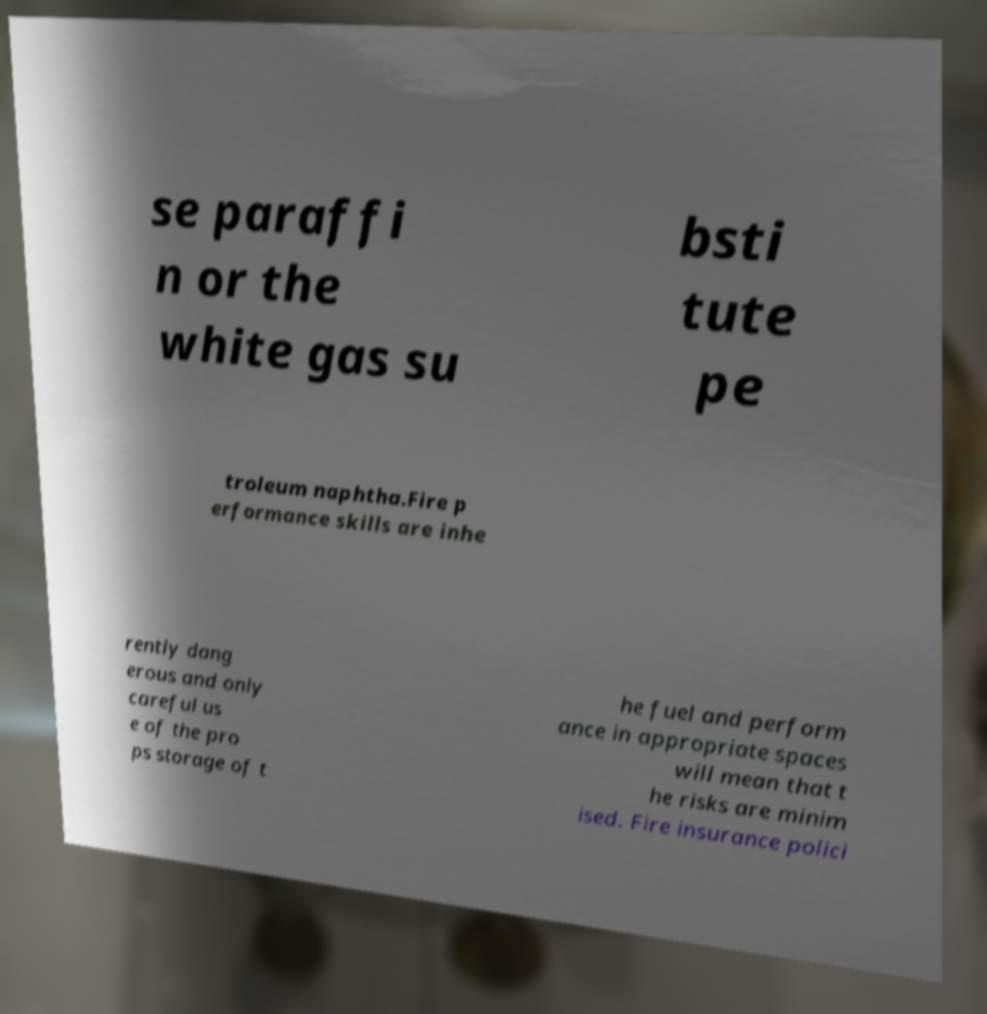Can you accurately transcribe the text from the provided image for me? se paraffi n or the white gas su bsti tute pe troleum naphtha.Fire p erformance skills are inhe rently dang erous and only careful us e of the pro ps storage of t he fuel and perform ance in appropriate spaces will mean that t he risks are minim ised. Fire insurance polici 